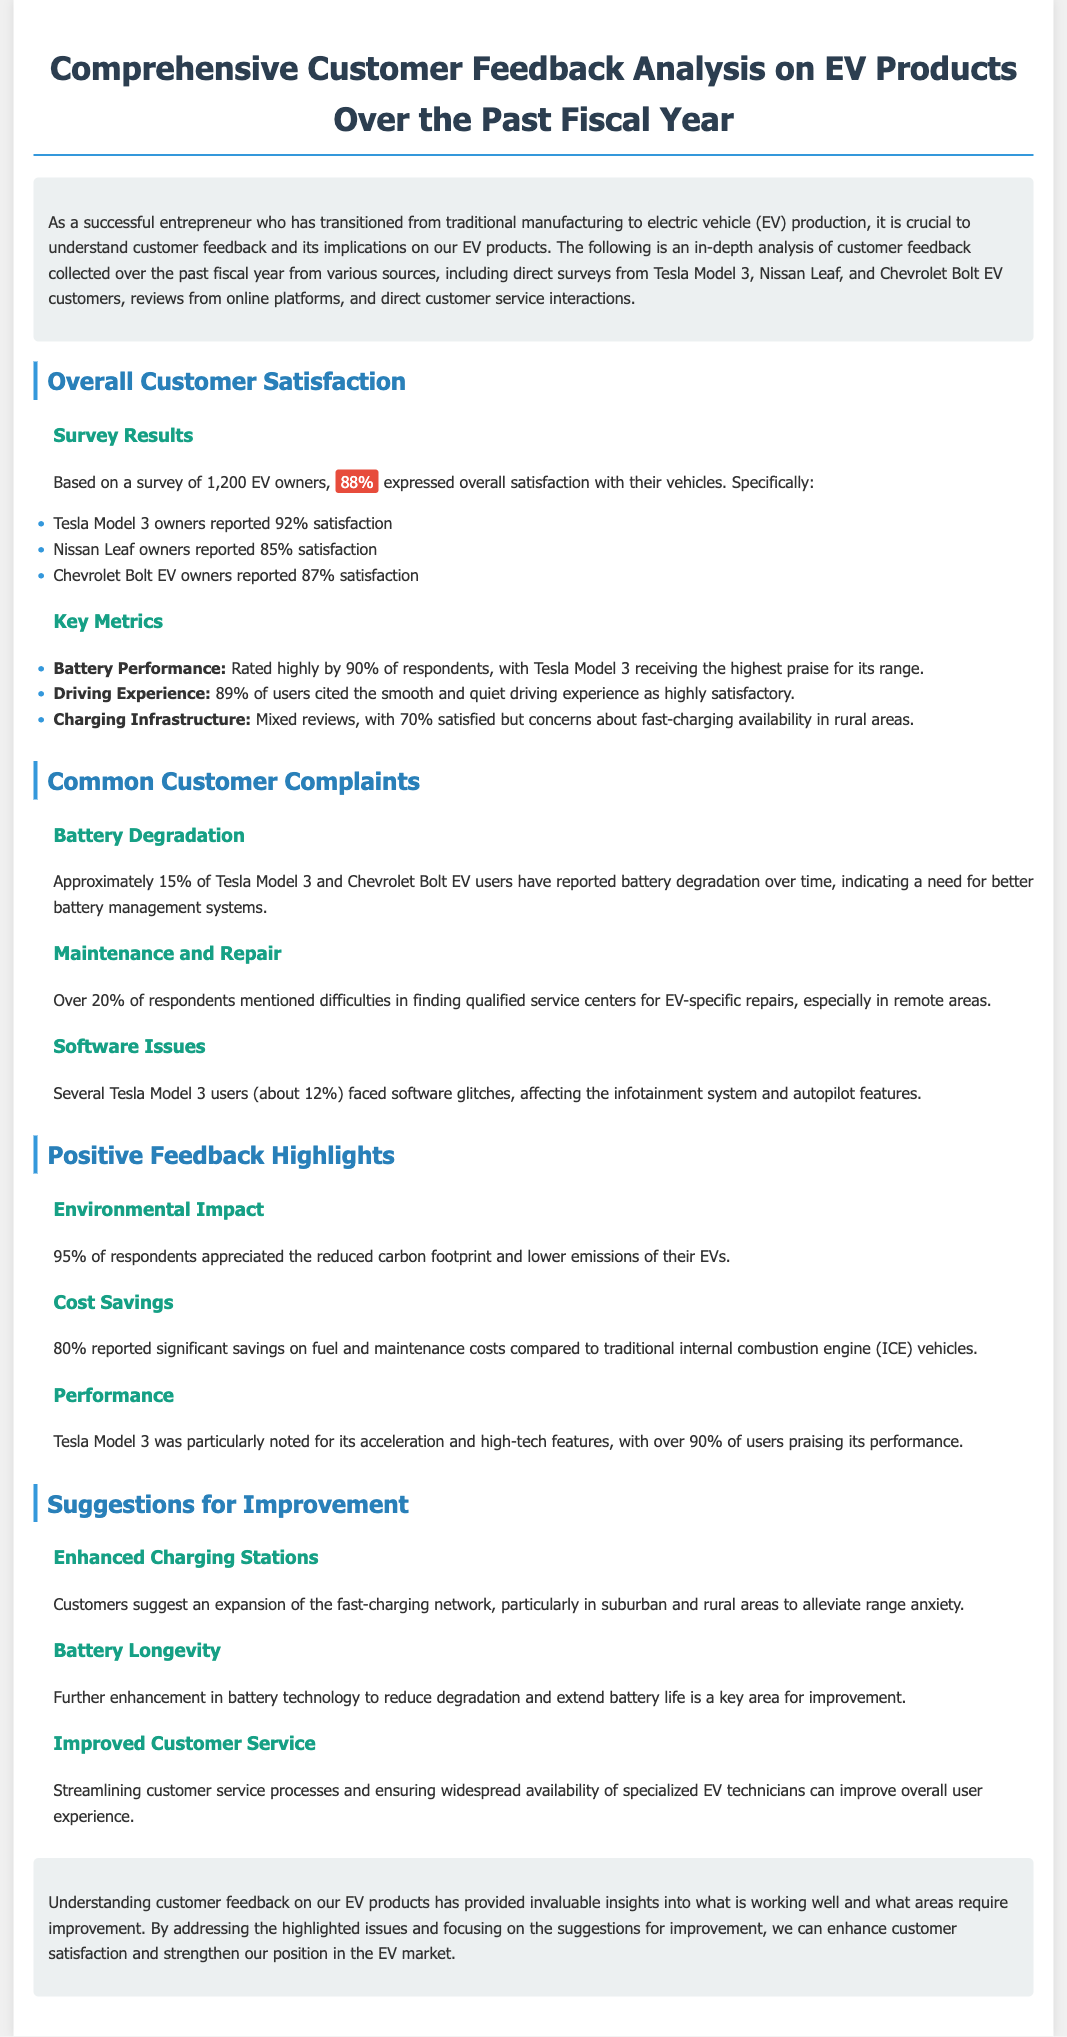what percentage of EV owners expressed overall satisfaction? The document states that 88% of the survey respondents expressed overall satisfaction with their vehicles.
Answer: 88% which EV model received the highest satisfaction percentage? According to the survey results, Tesla Model 3 owners reported a satisfaction percentage of 92%, the highest among the models listed.
Answer: Tesla Model 3 what issue did approximately 15% of Tesla Model 3 users report? The document mentions that 15% of Tesla Model 3 users reported battery degradation over time.
Answer: battery degradation how many respondents reported difficulties in finding qualified service centers? Over 20% of respondents mentioned difficulties in finding qualified service centers for EV-specific repairs.
Answer: Over 20% what was the satisfaction percentage for the driving experience? The document indicates that 89% of users cited the smooth and quiet driving experience as highly satisfactory.
Answer: 89% what aspect of their vehicles did 95% of respondents appreciate? Respondents appreciated the reduced carbon footprint and lower emissions of their EVs, noted by 95% of them.
Answer: reduced carbon footprint what is a suggested area for enhancement according to customer feedback? Customers suggested enhancement in battery technology to reduce degradation and extend battery life.
Answer: battery technology which EV model was particularly noted for its performance? Tesla Model 3 was specifically highlighted for its performance, with over 90% of users praising it.
Answer: Tesla Model 3 what is a common complaint regarding charging infrastructure? The document states that there were mixed reviews, with 70% satisfied, indicating concerns about fast-charging availability, especially in rural areas.
Answer: fast-charging availability 